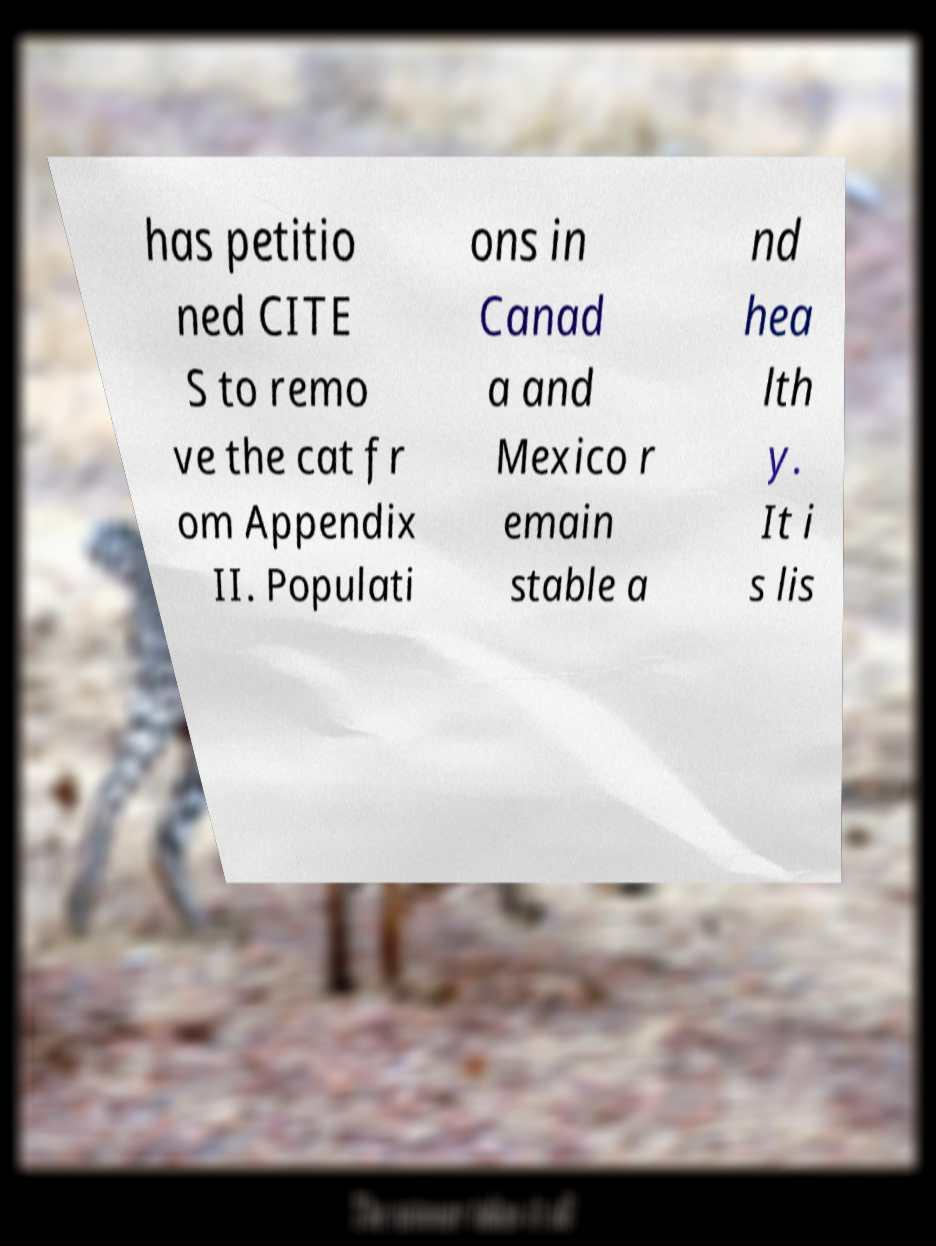Can you read and provide the text displayed in the image?This photo seems to have some interesting text. Can you extract and type it out for me? has petitio ned CITE S to remo ve the cat fr om Appendix II. Populati ons in Canad a and Mexico r emain stable a nd hea lth y. It i s lis 